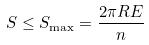Convert formula to latex. <formula><loc_0><loc_0><loc_500><loc_500>S \leq S _ { \max } = \frac { 2 \pi R E } { n }</formula> 